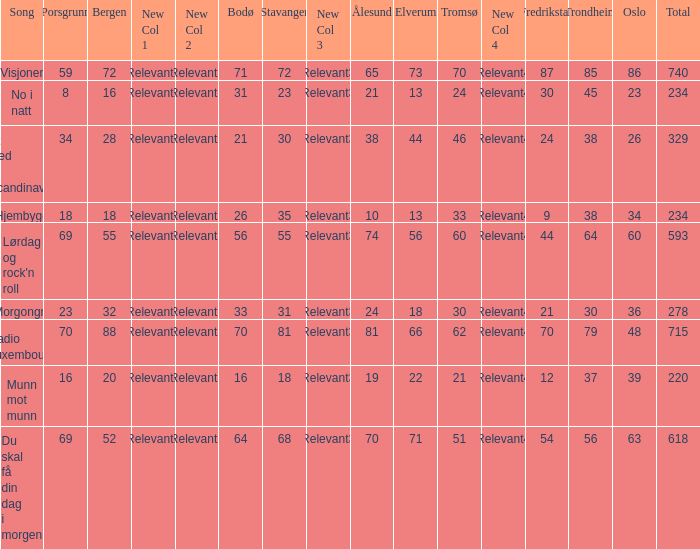What was the total for radio luxembourg? 715.0. 